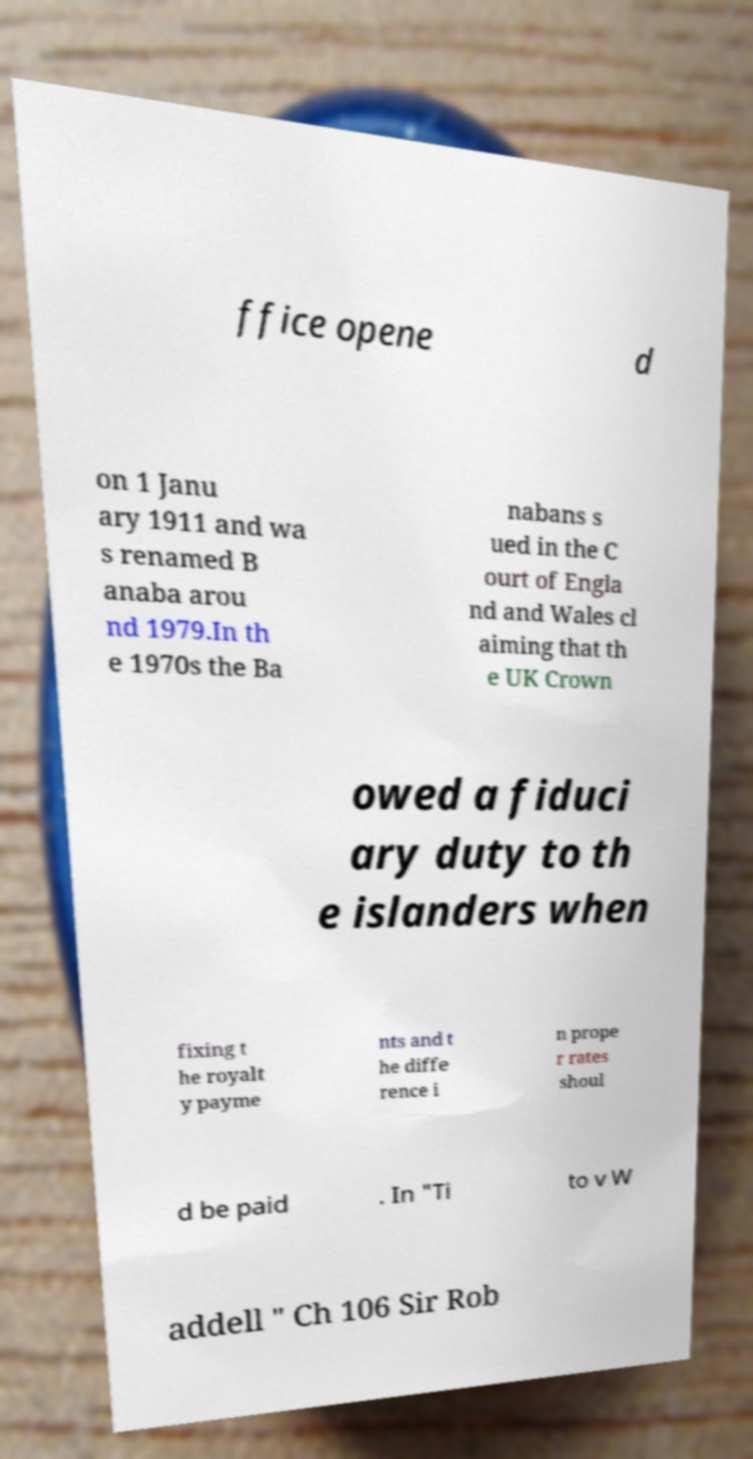What messages or text are displayed in this image? I need them in a readable, typed format. ffice opene d on 1 Janu ary 1911 and wa s renamed B anaba arou nd 1979.In th e 1970s the Ba nabans s ued in the C ourt of Engla nd and Wales cl aiming that th e UK Crown owed a fiduci ary duty to th e islanders when fixing t he royalt y payme nts and t he diffe rence i n prope r rates shoul d be paid . In "Ti to v W addell " Ch 106 Sir Rob 